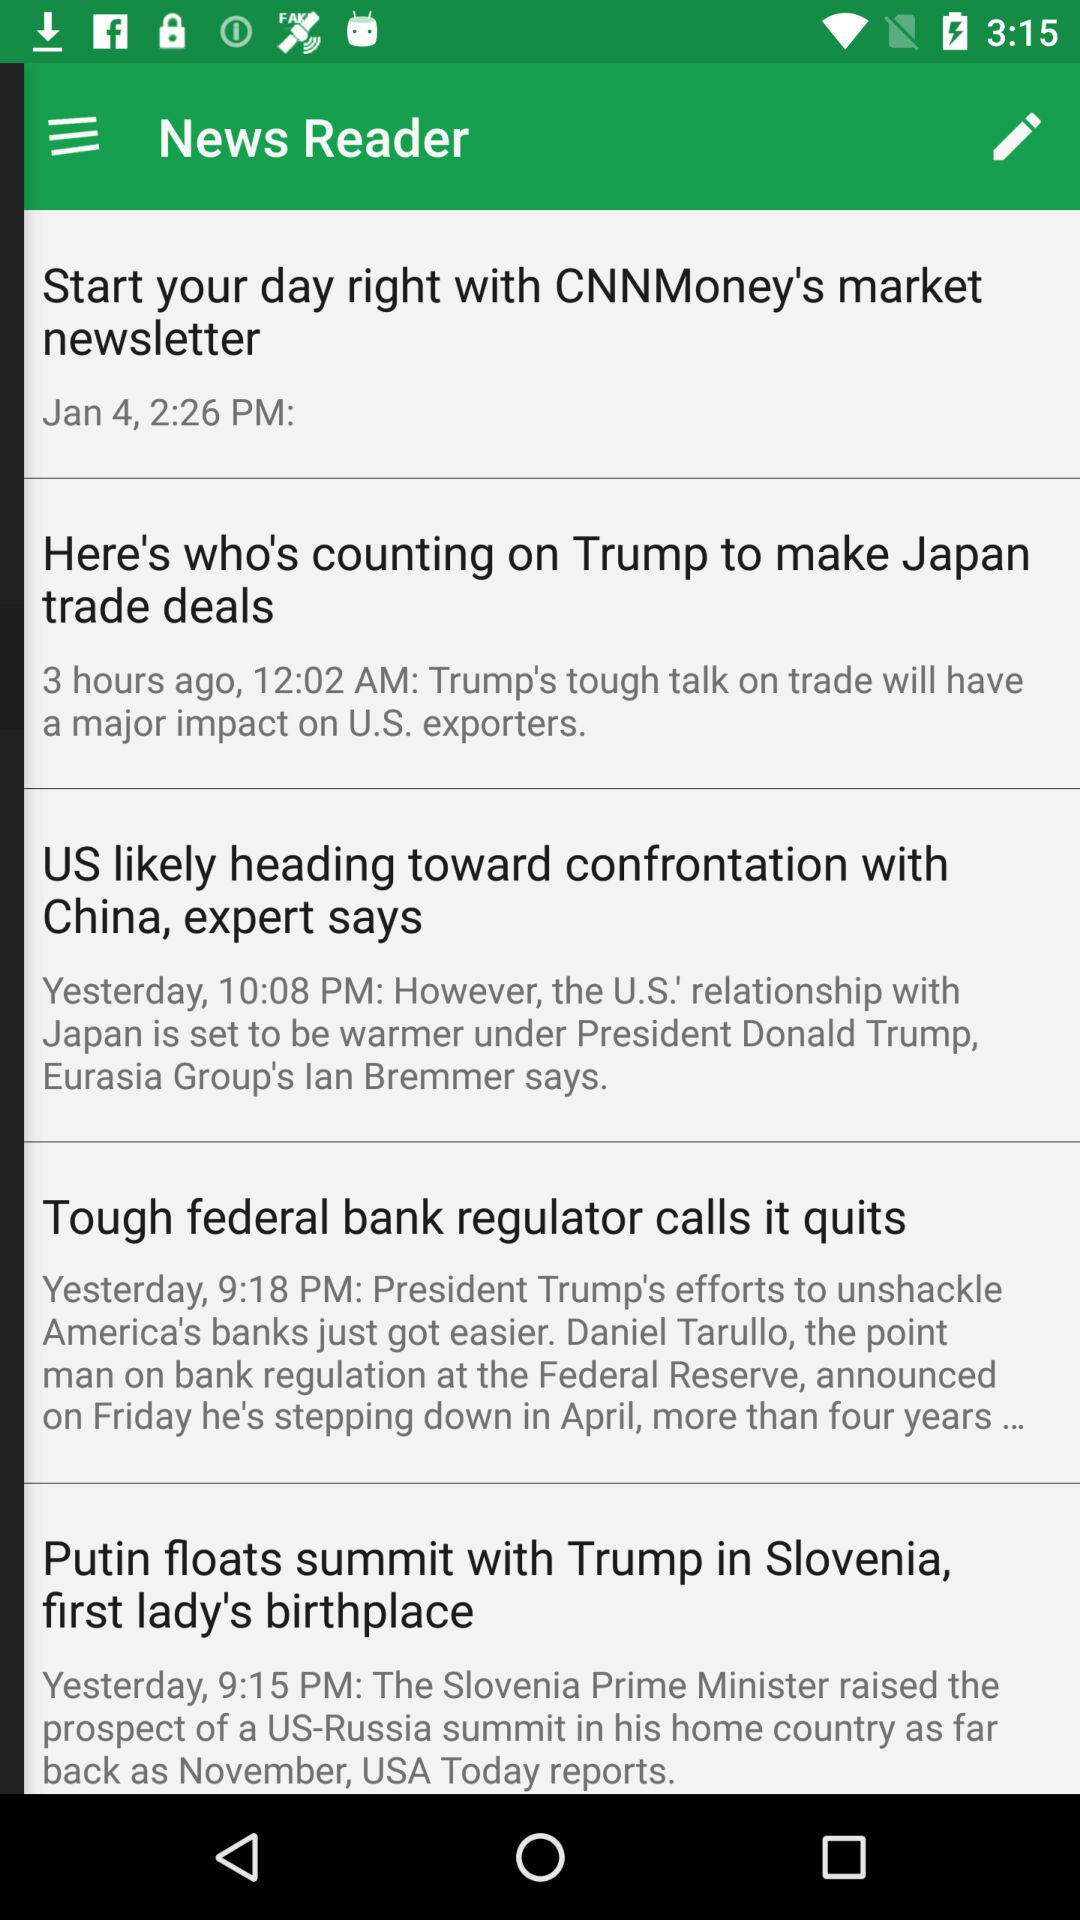What is the publication date of the news "Start your day right with CNNMoney's market newsletter"? The publication date is January 4. 